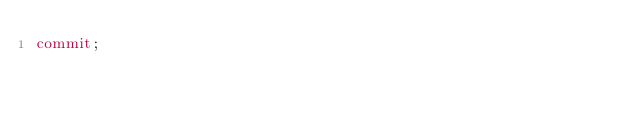Convert code to text. <code><loc_0><loc_0><loc_500><loc_500><_SQL_>commit;
</code> 